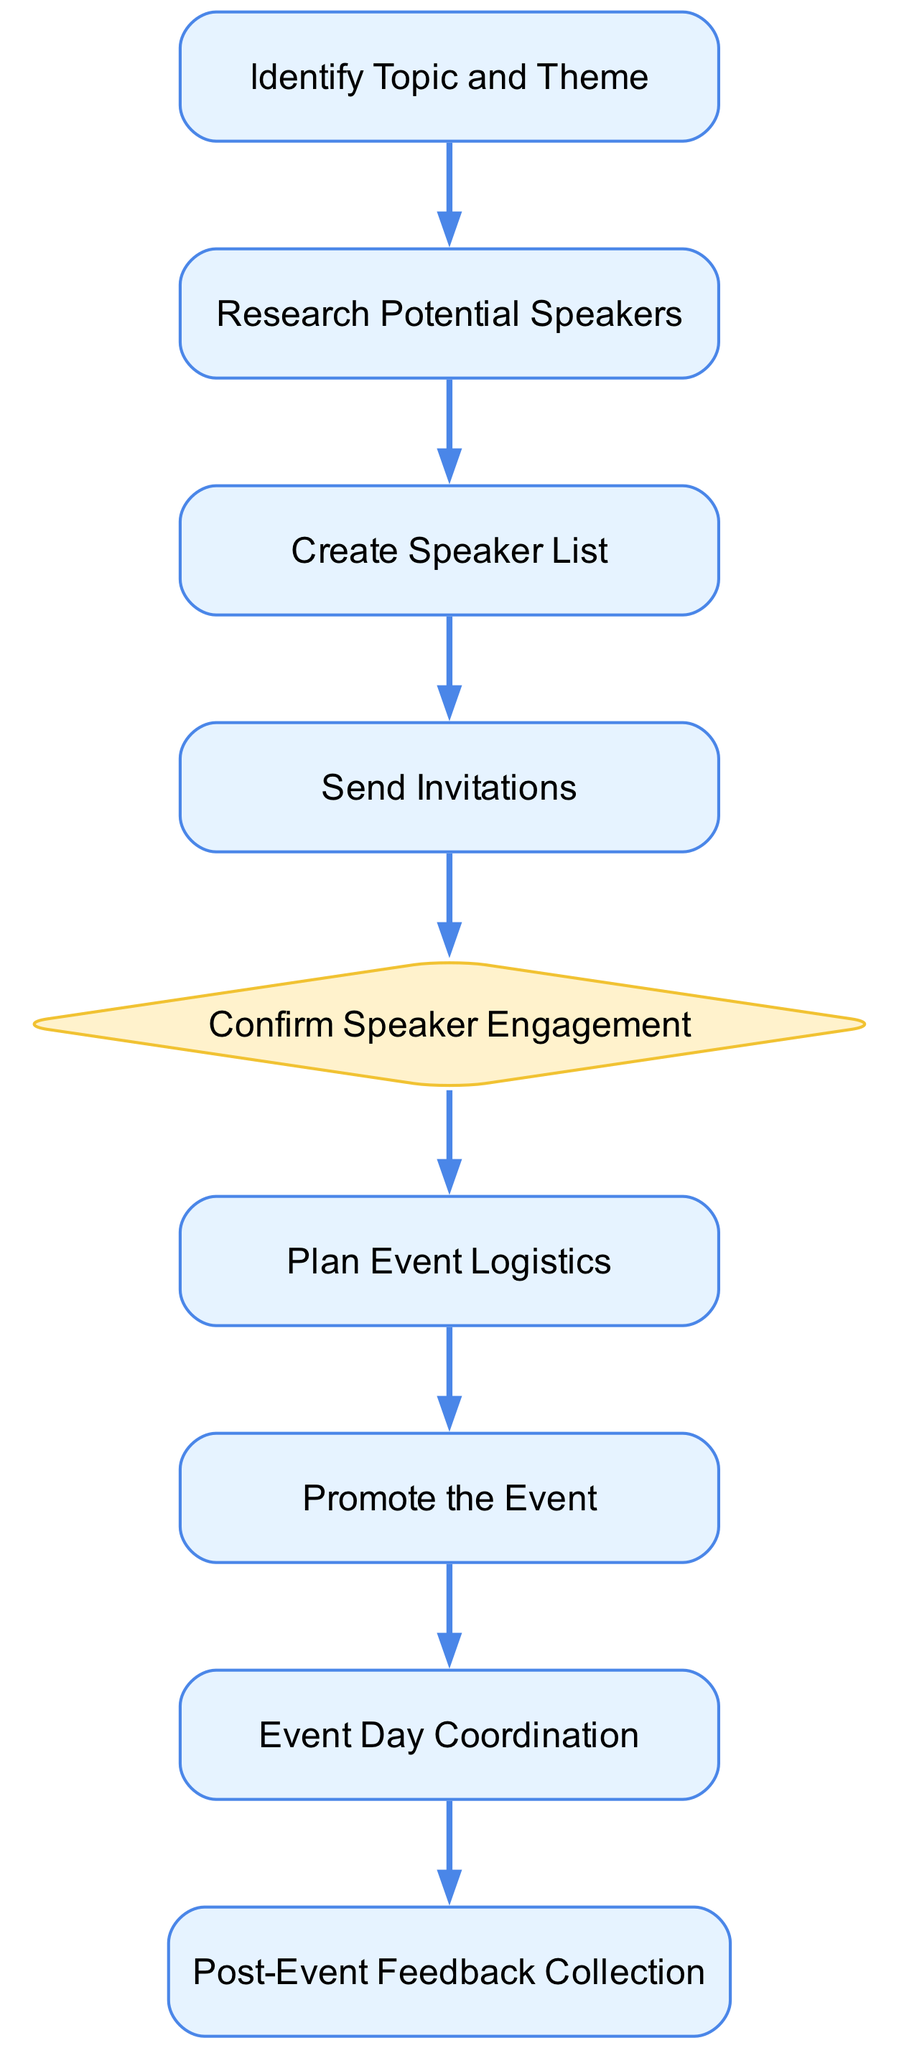What is the first step in the event planning process? The first step listed in the flow chart is "Identify Topic and Theme." By analyzing the flow from top to bottom, we can see that it is the initial node in the diagram, indicating the start of the process.
Answer: Identify Topic and Theme How many processes are there in the flow chart? The total number of nodes labeled as "Process" includes all steps except for the decision point. By counting those nodes, we find there are seven processes present in the chart.
Answer: 7 What follows "Send Invitations" in the event planning process? After "Send Invitations," the next step indicated in the flow chart is "Confirm Speaker Engagement." This is determined by following the arrows connecting the nodes in the diagram.
Answer: Confirm Speaker Engagement What type of node is "Confirm Speaker Engagement"? "Confirm Speaker Engagement" is labeled as a "Decision" node in the diagram. This can be identified by the shape of the node, which is a diamond as opposed to the rectangular shapes of the process nodes.
Answer: Decision What is the last step of the event planning process? The last step in the flow chart is "Post-Event Feedback Collection," as it is the final node at the bottom of the diagram's flow. This can be understood by following the sequence of steps all the way to the end.
Answer: Post-Event Feedback Collection Which two processes are directly connected before the decision point? The two processes connected before "Confirm Speaker Engagement" are "Send Invitations" and "Research Potential Speakers." By tracing the flow of arrows, we can see these connections clearly represented.
Answer: Send Invitations and Research Potential Speakers What role does "Promote the Event" play in the sequence? "Promote the Event" is a crucial process that occurs after "Plan Event Logistics" and before "Event Day Coordination." It plays a key role in ensuring attendees are informed about the event, relevant to the overall timeline of planning.
Answer: A process in the sequence How many decision points are there in the event planning flow chart? There is one decision point in the chart, which is "Confirm Speaker Engagement." By reviewing the diagram, it is evident that this is the only diamond-shaped node, signifying a decision to be made.
Answer: 1 